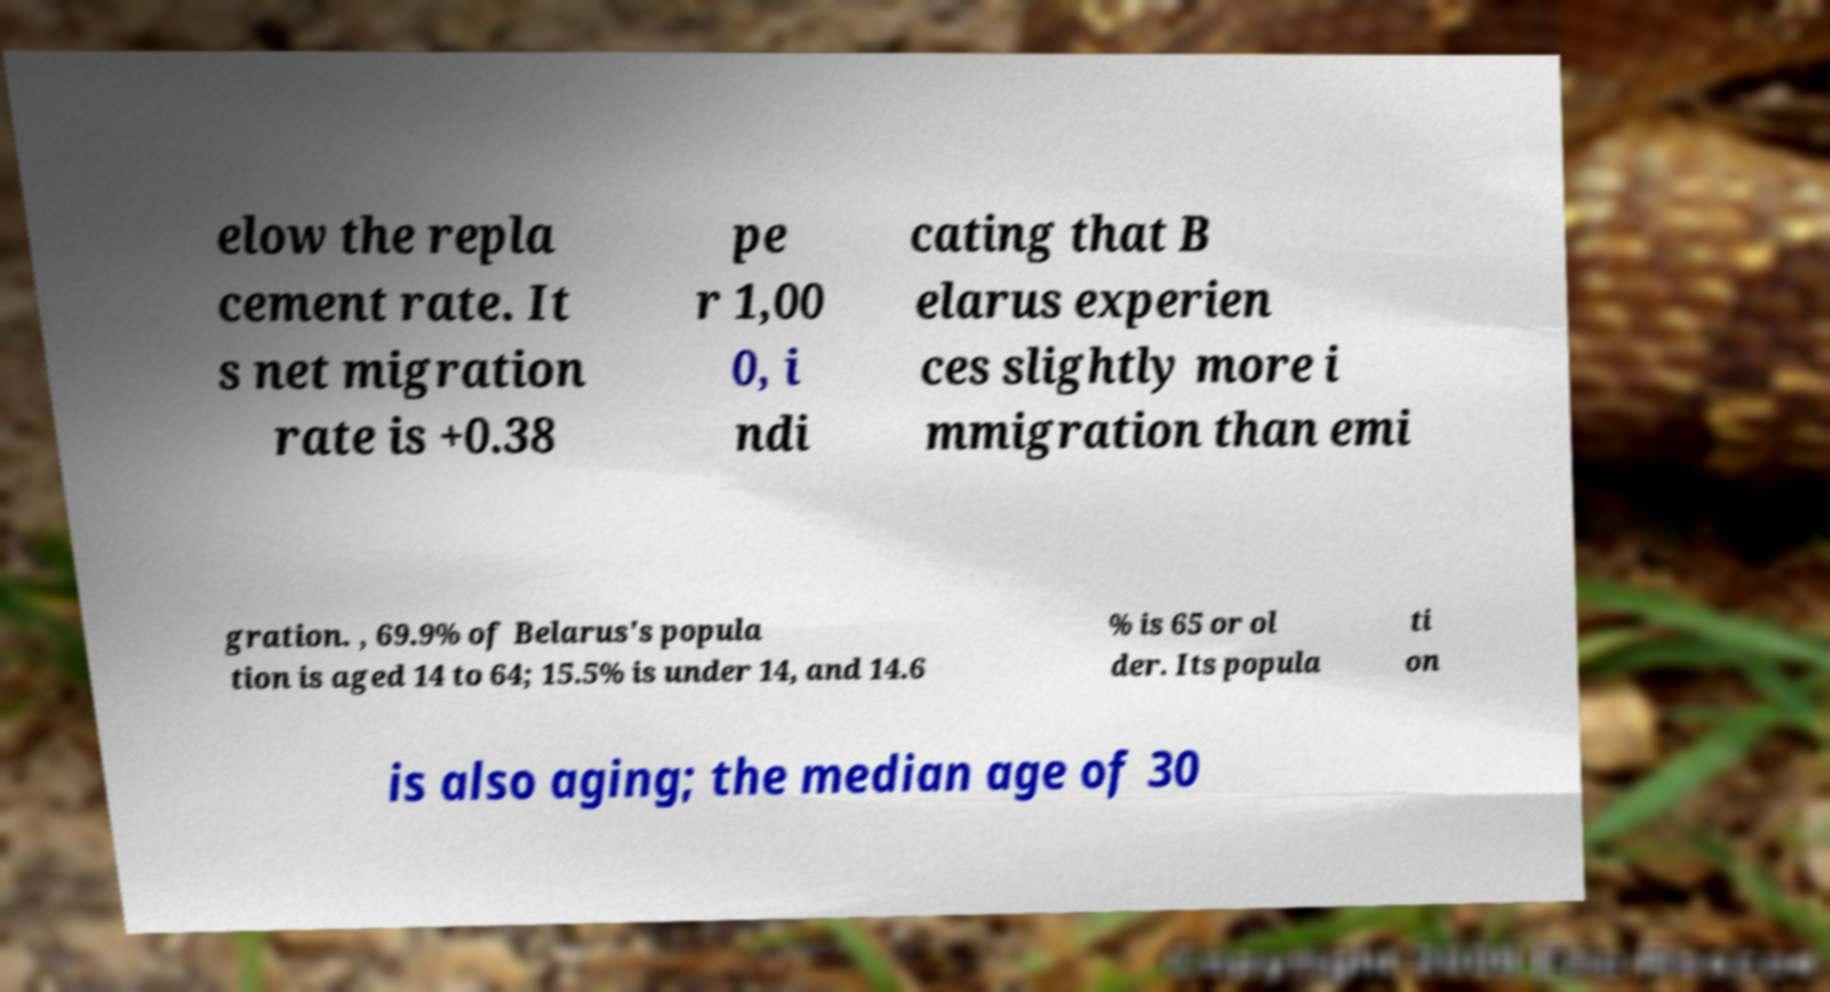Can you accurately transcribe the text from the provided image for me? elow the repla cement rate. It s net migration rate is +0.38 pe r 1,00 0, i ndi cating that B elarus experien ces slightly more i mmigration than emi gration. , 69.9% of Belarus's popula tion is aged 14 to 64; 15.5% is under 14, and 14.6 % is 65 or ol der. Its popula ti on is also aging; the median age of 30 